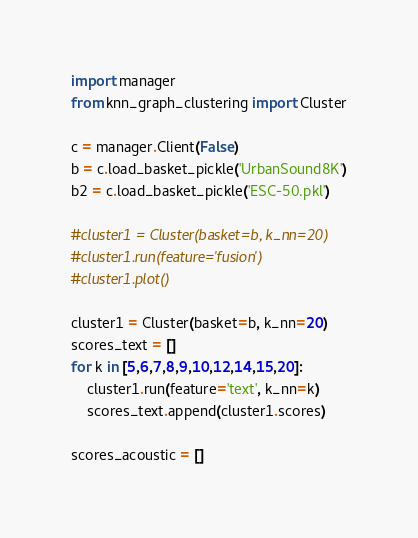Convert code to text. <code><loc_0><loc_0><loc_500><loc_500><_Python_>import manager
from knn_graph_clustering import Cluster

c = manager.Client(False)
b = c.load_basket_pickle('UrbanSound8K')
b2 = c.load_basket_pickle('ESC-50.pkl')

#cluster1 = Cluster(basket=b, k_nn=20)
#cluster1.run(feature='fusion')
#cluster1.plot()

cluster1 = Cluster(basket=b, k_nn=20)
scores_text = []
for k in [5,6,7,8,9,10,12,14,15,20]:
    cluster1.run(feature='text', k_nn=k)
    scores_text.append(cluster1.scores)

scores_acoustic = []</code> 